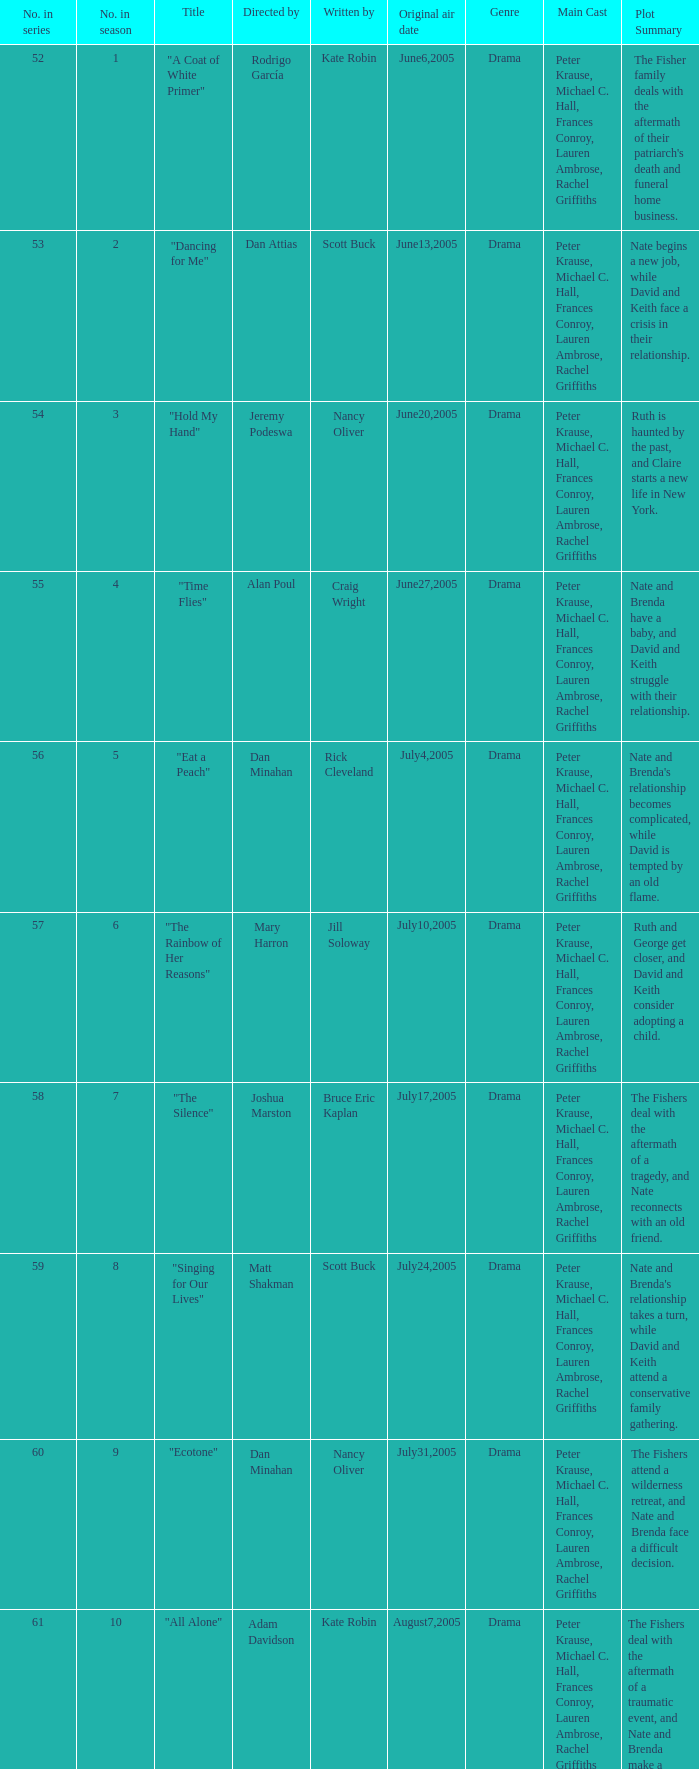What s the episode number in the season that was written by Nancy Oliver? 9.0. Could you parse the entire table as a dict? {'header': ['No. in series', 'No. in season', 'Title', 'Directed by', 'Written by', 'Original air date', 'Genre', 'Main Cast', 'Plot Summary '], 'rows': [['52', '1', '"A Coat of White Primer"', 'Rodrigo García', 'Kate Robin', 'June6,2005', 'Drama', 'Peter Krause, Michael C. Hall, Frances Conroy, Lauren Ambrose, Rachel Griffiths', "The Fisher family deals with the aftermath of their patriarch's death and funeral home business. "], ['53', '2', '"Dancing for Me"', 'Dan Attias', 'Scott Buck', 'June13,2005', 'Drama', 'Peter Krause, Michael C. Hall, Frances Conroy, Lauren Ambrose, Rachel Griffiths', 'Nate begins a new job, while David and Keith face a crisis in their relationship. '], ['54', '3', '"Hold My Hand"', 'Jeremy Podeswa', 'Nancy Oliver', 'June20,2005', 'Drama', 'Peter Krause, Michael C. Hall, Frances Conroy, Lauren Ambrose, Rachel Griffiths', 'Ruth is haunted by the past, and Claire starts a new life in New York. '], ['55', '4', '"Time Flies"', 'Alan Poul', 'Craig Wright', 'June27,2005', 'Drama', 'Peter Krause, Michael C. Hall, Frances Conroy, Lauren Ambrose, Rachel Griffiths', 'Nate and Brenda have a baby, and David and Keith struggle with their relationship. '], ['56', '5', '"Eat a Peach"', 'Dan Minahan', 'Rick Cleveland', 'July4,2005', 'Drama', 'Peter Krause, Michael C. Hall, Frances Conroy, Lauren Ambrose, Rachel Griffiths', "Nate and Brenda's relationship becomes complicated, while David is tempted by an old flame. "], ['57', '6', '"The Rainbow of Her Reasons"', 'Mary Harron', 'Jill Soloway', 'July10,2005', 'Drama', 'Peter Krause, Michael C. Hall, Frances Conroy, Lauren Ambrose, Rachel Griffiths', 'Ruth and George get closer, and David and Keith consider adopting a child. '], ['58', '7', '"The Silence"', 'Joshua Marston', 'Bruce Eric Kaplan', 'July17,2005', 'Drama', 'Peter Krause, Michael C. Hall, Frances Conroy, Lauren Ambrose, Rachel Griffiths', 'The Fishers deal with the aftermath of a tragedy, and Nate reconnects with an old friend. '], ['59', '8', '"Singing for Our Lives"', 'Matt Shakman', 'Scott Buck', 'July24,2005', 'Drama', 'Peter Krause, Michael C. Hall, Frances Conroy, Lauren Ambrose, Rachel Griffiths', "Nate and Brenda's relationship takes a turn, while David and Keith attend a conservative family gathering. "], ['60', '9', '"Ecotone"', 'Dan Minahan', 'Nancy Oliver', 'July31,2005', 'Drama', 'Peter Krause, Michael C. Hall, Frances Conroy, Lauren Ambrose, Rachel Griffiths', 'The Fishers attend a wilderness retreat, and Nate and Brenda face a difficult decision. '], ['61', '10', '"All Alone"', 'Adam Davidson', 'Kate Robin', 'August7,2005', 'Drama', 'Peter Krause, Michael C. Hall, Frances Conroy, Lauren Ambrose, Rachel Griffiths', 'The Fishers deal with the aftermath of a traumatic event, and Nate and Brenda make a life-changing decision. '], ['62', '11', '"Static"', 'Michael Cuesta', 'Craig Wright', 'August14,2005', 'Drama', 'Peter Krause, Michael C. Hall, Frances Conroy, Lauren Ambrose, Rachel Griffiths', 'The Fishers face a crisis in the funeral home business, while Ruth considers her future.']]} 